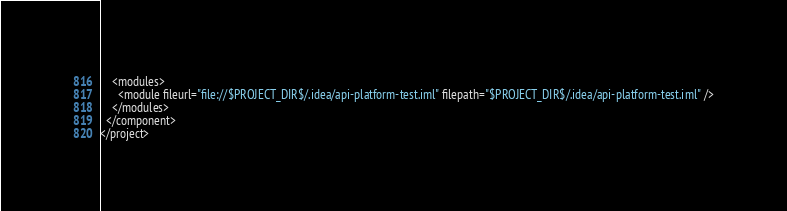<code> <loc_0><loc_0><loc_500><loc_500><_XML_>    <modules>
      <module fileurl="file://$PROJECT_DIR$/.idea/api-platform-test.iml" filepath="$PROJECT_DIR$/.idea/api-platform-test.iml" />
    </modules>
  </component>
</project></code> 